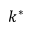<formula> <loc_0><loc_0><loc_500><loc_500>k ^ { * }</formula> 